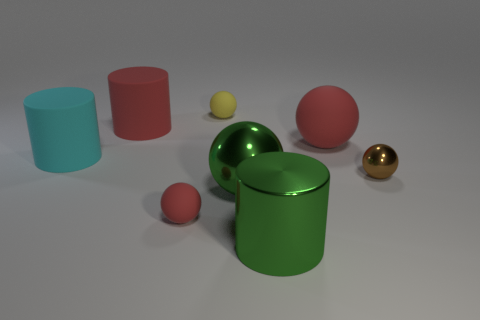Subtract 1 spheres. How many spheres are left? 4 Subtract all matte cylinders. How many cylinders are left? 1 Subtract all brown balls. How many balls are left? 4 Add 1 tiny matte balls. How many objects exist? 9 Subtract all yellow spheres. Subtract all red cylinders. How many spheres are left? 4 Subtract all balls. How many objects are left? 3 Subtract 0 purple cylinders. How many objects are left? 8 Subtract all green cylinders. Subtract all shiny cylinders. How many objects are left? 6 Add 6 tiny brown shiny spheres. How many tiny brown shiny spheres are left? 7 Add 6 large cyan shiny balls. How many large cyan shiny balls exist? 6 